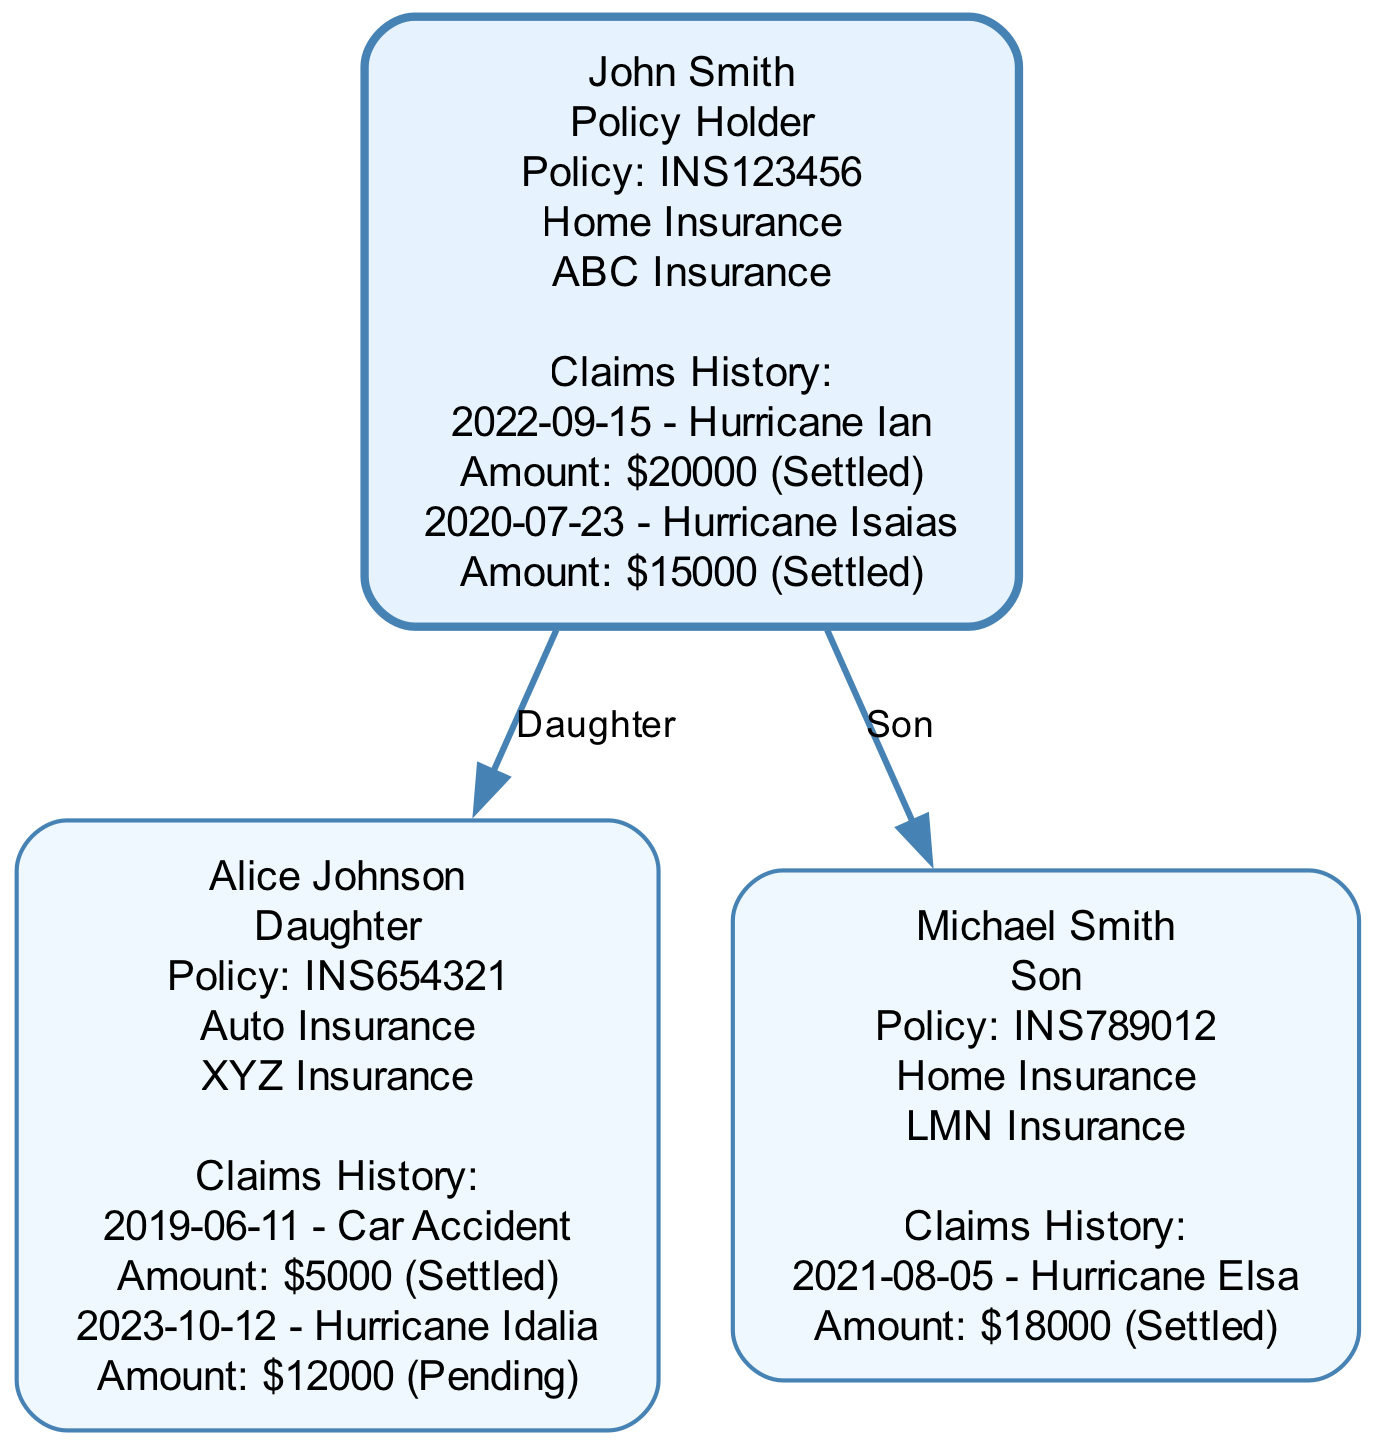What is the policy number for John Smith? The policy number is found under the 'insuranceDetails' section for the root node, corresponding to John Smith. It is indicated as "INS123456".
Answer: INS123456 How many claims history entries does Alice Johnson have? By checking the 'claimsHistory' list under Alice Johnson's insurance details, there are two entries listed: one for a car accident and one for Hurricane Idalia.
Answer: 2 What relationship does Michael Smith have to John Smith? To determine the relationship, one needs to look at the 'relationship' attribute of Michael Smith in the children list. It states that Michael is the "Son" of John Smith.
Answer: Son What is the amount claimed for Hurricane Ian? The claims history under John Smith includes a claim with the event "Hurricane Ian". The amount associated with this claim is $20,000.
Answer: $20000 What insurance coverage does Alice Johnson currently have? This information is in the 'currentCoverage' section of Alice Johnson's insurance details. It notes that her current coverage is "Auto Insurance".
Answer: Auto Insurance Which family member has an insurance policy with XYZ Insurance? By examining the insurance details of each family member, it's noted that Alice Johnson has a policy with "XYZ Insurance".
Answer: Alice Johnson How many children does John Smith have? Counting from the 'children' array under John Smith's family tree, there are two entries indicating that he has two children, Alice and Michael.
Answer: 2 What is the status of the claim related to Hurricane Idalia for Alice Johnson? The claims history entry for Hurricane Idalia under Alice Johnson indicates the status as "Pending".
Answer: Pending Which event involved the largest claim amount in the family tree? By comparing claim amounts in the claims history of all family members, the largest claim is for Hurricane Ian at $20,000.
Answer: Hurricane Ian 